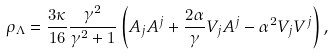<formula> <loc_0><loc_0><loc_500><loc_500>\rho _ { \Lambda } = \frac { 3 \kappa } { 1 6 } \frac { \gamma ^ { 2 } } { \gamma ^ { 2 } + 1 } \left ( A _ { j } A ^ { j } + \frac { 2 \alpha } { \gamma } V _ { j } A ^ { j } - \alpha ^ { 2 } V _ { j } V ^ { j } \right ) ,</formula> 